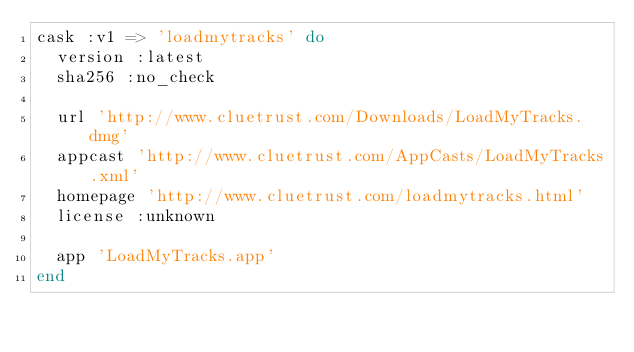<code> <loc_0><loc_0><loc_500><loc_500><_Ruby_>cask :v1 => 'loadmytracks' do
  version :latest
  sha256 :no_check

  url 'http://www.cluetrust.com/Downloads/LoadMyTracks.dmg'
  appcast 'http://www.cluetrust.com/AppCasts/LoadMyTracks.xml'
  homepage 'http://www.cluetrust.com/loadmytracks.html'
  license :unknown

  app 'LoadMyTracks.app'
end
</code> 